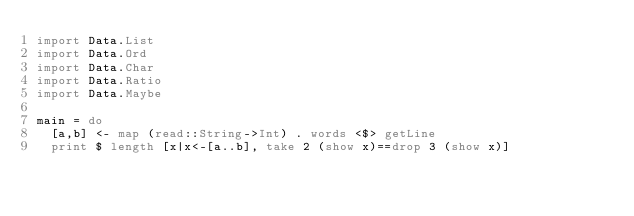Convert code to text. <code><loc_0><loc_0><loc_500><loc_500><_Haskell_>import Data.List
import Data.Ord
import Data.Char
import Data.Ratio
import Data.Maybe

main = do
  [a,b] <- map (read::String->Int) . words <$> getLine
  print $ length [x|x<-[a..b], take 2 (show x)==drop 3 (show x)]</code> 